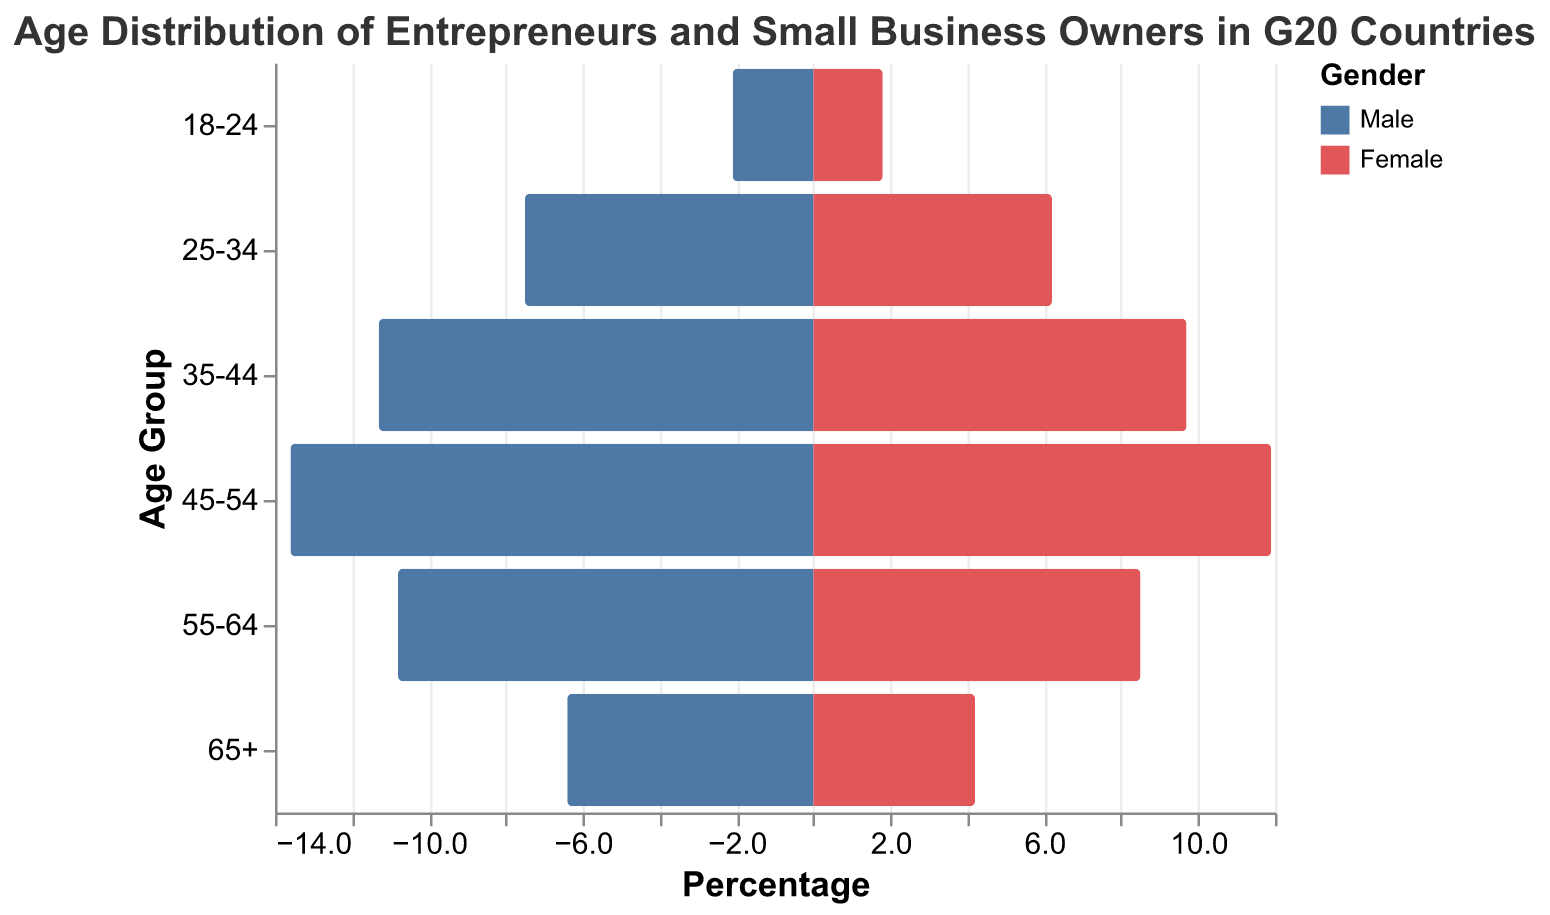What is the title of the figure? The title of the figure is placed at the top. It reads "Age Distribution of Entrepreneurs and Small Business Owners in G20 Countries".
Answer: Age Distribution of Entrepreneurs and Small Business Owners in G20 Countries Which age group has the highest male percentage? By looking at the lengths of the bars on the left side (where male percentage is represented), the age group 45-54 has the highest value.
Answer: 45-54 How do the percentages of male and female entrepreneurs compare in the 35-44 age group? For the 35-44 age group, it shows that males have a percentage of 11.3 and females have a percentage of 9.7. Comparing these values indicates that males have a higher percentage.
Answer: Males have a higher percentage Are there more male or female entrepreneurs in the 55-64 age group? By examining the bars for the 55-64 age group, the male percentage is 10.8 while the female percentage is 8.5, showing that there are more males.
Answer: More males Which gender has the higher percentage in the 18-24 age group? In the 18-24 age group, the male percentage is 2.1 and the female percentage is 1.8. Males have a higher percentage than females.
Answer: Males What is the combined percentage of male and female entrepreneurs in the 25-34 age group? The male percentage in the 25-34 age group is 7.5 and the female percentage is 6.2. The combined percentage is calculated as 7.5 + 6.2 = 13.7.
Answer: 13.7 In which age group is the gender disparity the greatest? Calculating the disparity involves finding the difference between male and female percentages in each age group:
18-24: 2.1 - 1.8 = 0.3,
25-34: 7.5 - 6.2 = 1.3,
35-44: 11.3 - 9.7 = 1.6,
45-54: 13.6 - 11.9 = 1.7,
55-64: 10.8 - 8.5 = 2.3,
65+: 6.4 - 4.2 = 2.2,
The greatest disparity is in the 55-64 age group, with a value of 2.3.
Answer: 55-64 How does the percentage of female entrepreneurs in the 65+ age group compare to those in the 18-24 age group? For the 65+ age group, the female percentage is 4.2, while for the 18-24 age group, it is 1.8. The female percentage is higher in the 65+ age group.
Answer: Higher in the 65+ age group What is the average percentage of male entrepreneurs across all age groups? Summing up the male percentages (2.1, 7.5, 11.3, 13.6, 10.8, 6.4) gives 51.7. Dividing this by 6 (the number of age groups) results in an average of 51.7/6 = 8.6167, rounded to 8.62.
Answer: 8.62 What could be inferred about the trend in female entrepreneurship as age increases among G20 countries? Observing the female percentages across age groups:
18-24: 1.8,
25-34: 6.2,
35-44: 9.7,
45-54: 11.9,
55-64: 8.5,
65+: 4.2,
It initially increases, peaks at 45-54, and then decreases. The trend shows more female entrepreneurship in middle age, tapering off as age increases further.
Answer: Peaks at middle age, then decreases 